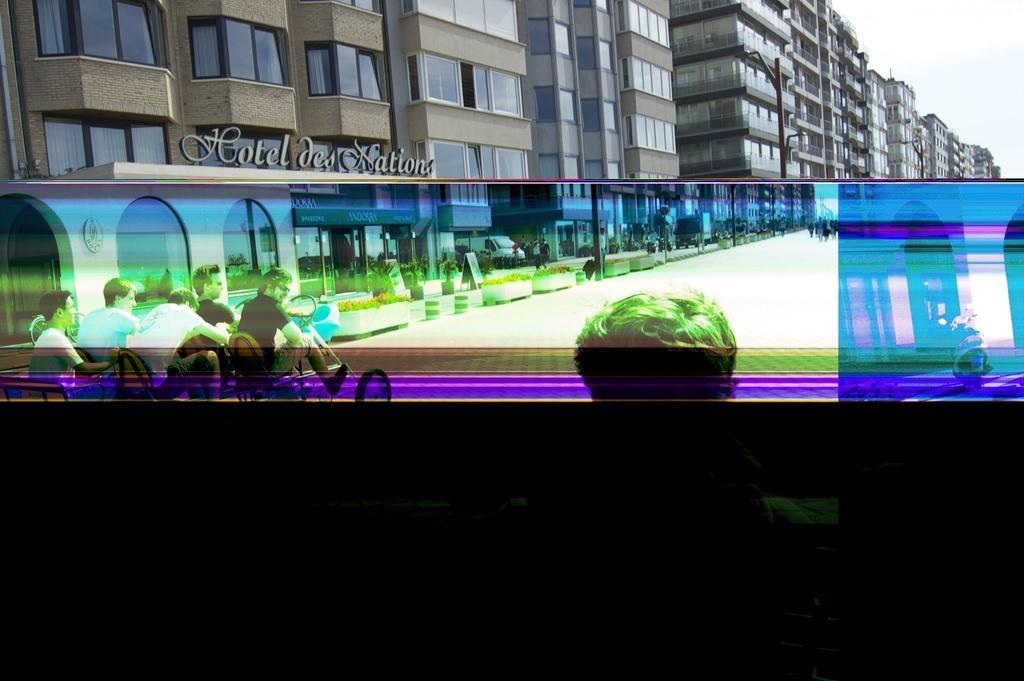Please provide a concise description of this image. In this image there is a group of persons are sitting at left side of this image. There are some buildings in the background an there is a sky at top right corner of this image. There is one vehicle at right side of this image. There is one person at bottom of this image. there are some plants in middle of this image. There is one vehicle in middle of this image which is is white color. 